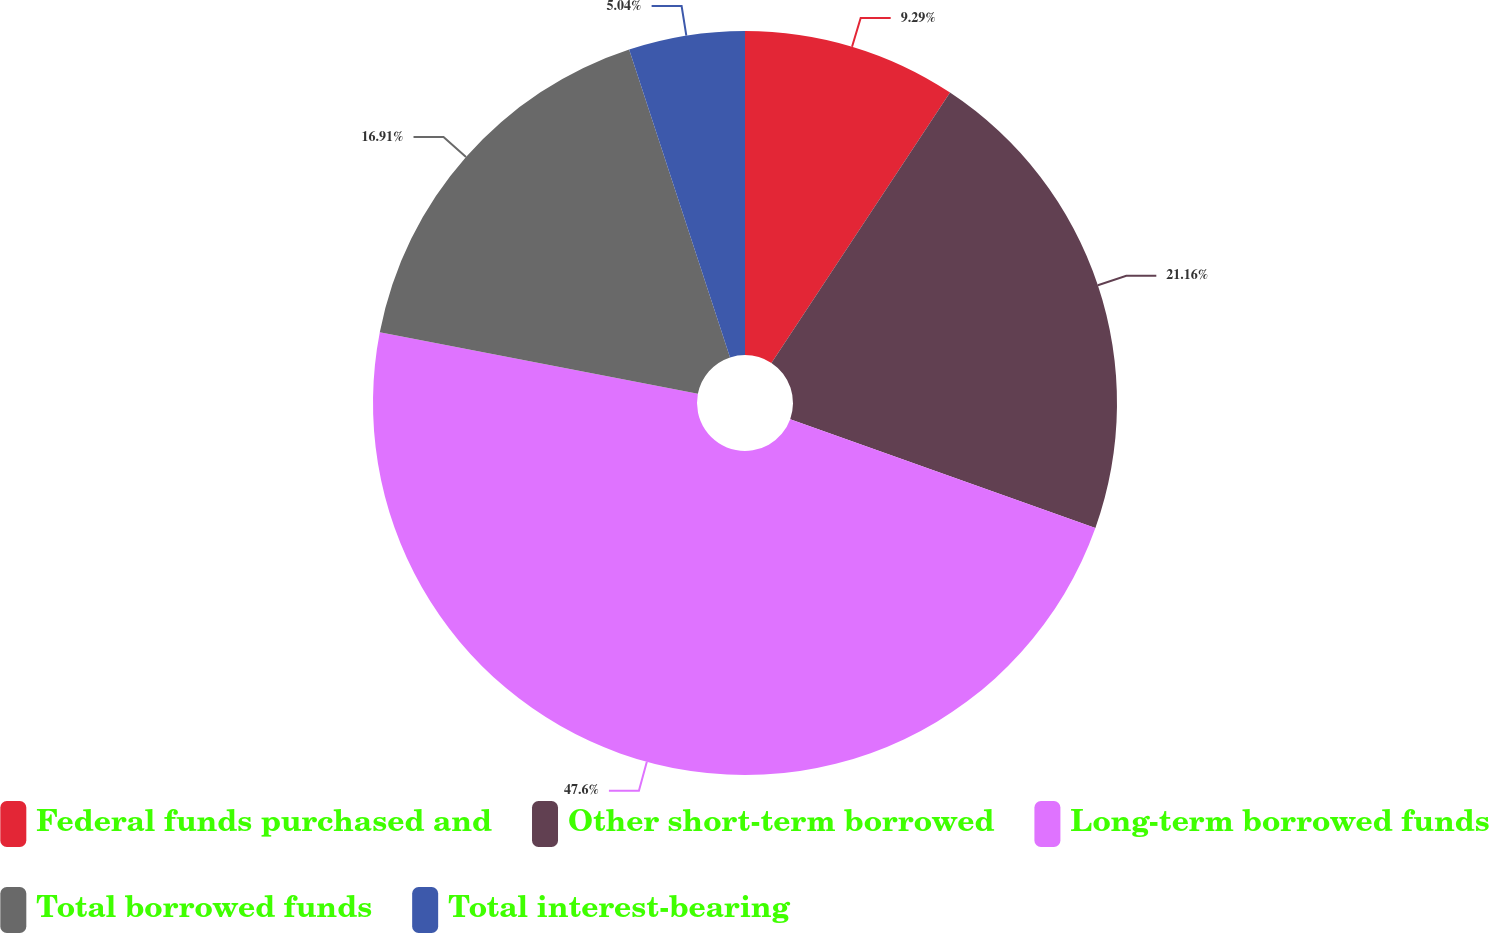Convert chart to OTSL. <chart><loc_0><loc_0><loc_500><loc_500><pie_chart><fcel>Federal funds purchased and<fcel>Other short-term borrowed<fcel>Long-term borrowed funds<fcel>Total borrowed funds<fcel>Total interest-bearing<nl><fcel>9.29%<fcel>21.16%<fcel>47.59%<fcel>16.91%<fcel>5.04%<nl></chart> 